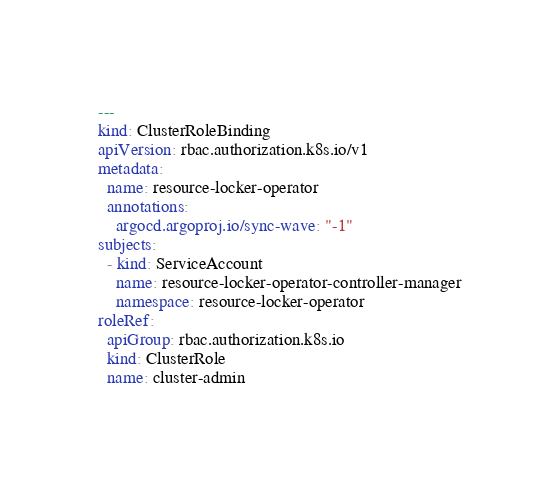Convert code to text. <code><loc_0><loc_0><loc_500><loc_500><_YAML_>---
kind: ClusterRoleBinding
apiVersion: rbac.authorization.k8s.io/v1
metadata:
  name: resource-locker-operator
  annotations:
    argocd.argoproj.io/sync-wave: "-1"
subjects:
  - kind: ServiceAccount
    name: resource-locker-operator-controller-manager
    namespace: resource-locker-operator
roleRef:
  apiGroup: rbac.authorization.k8s.io
  kind: ClusterRole
  name: cluster-admin
</code> 